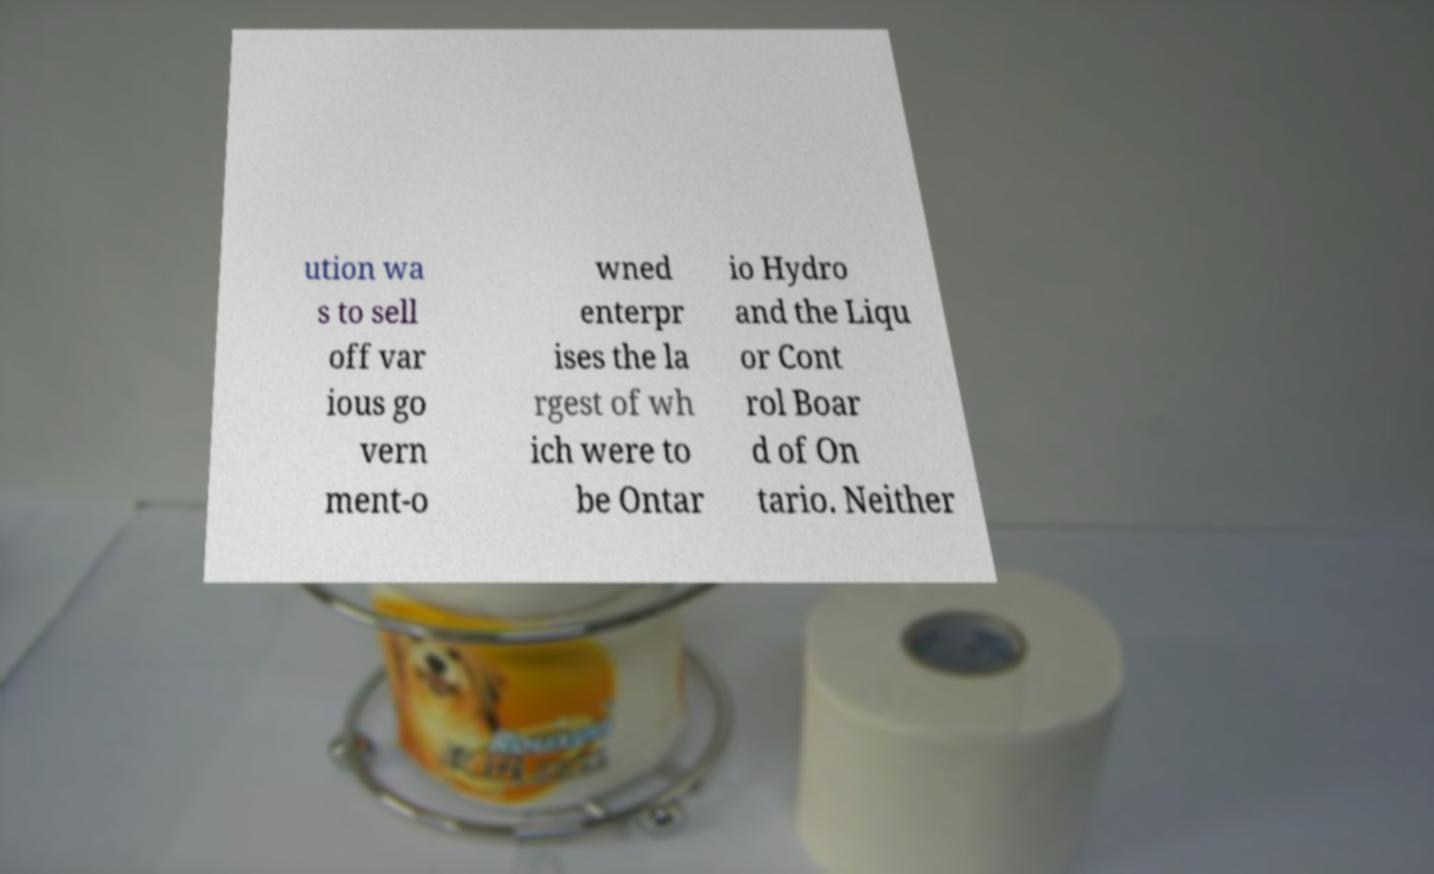What messages or text are displayed in this image? I need them in a readable, typed format. ution wa s to sell off var ious go vern ment-o wned enterpr ises the la rgest of wh ich were to be Ontar io Hydro and the Liqu or Cont rol Boar d of On tario. Neither 